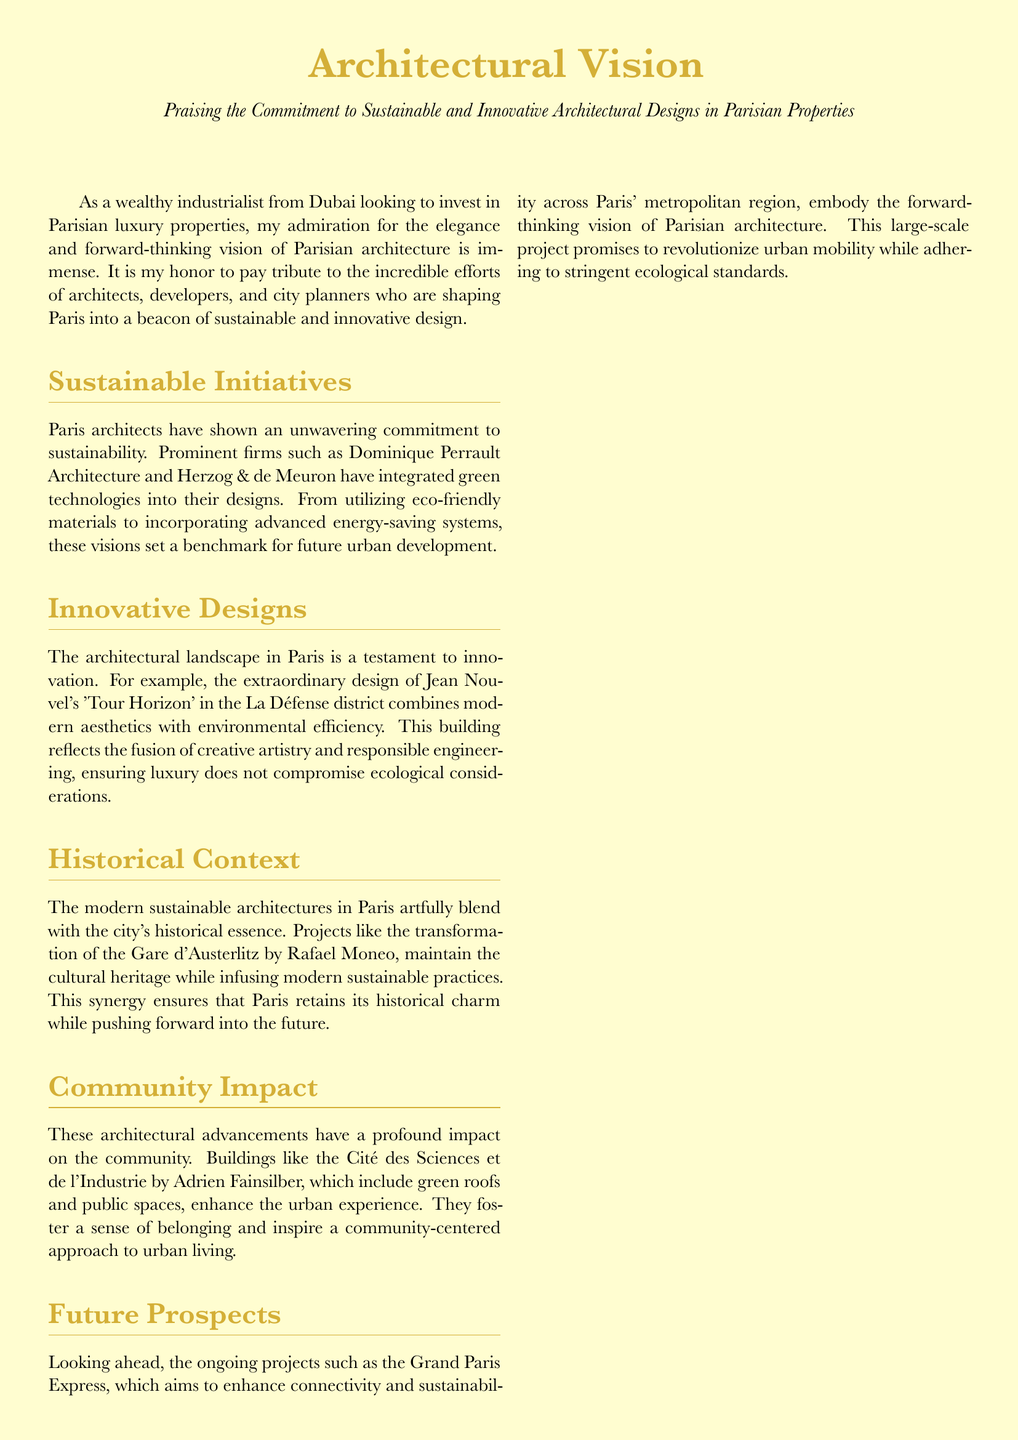What is the name of the architect who designed 'Tour Horizon'? The document mentions Jean Nouvel as the architect of 'Tour Horizon'.
Answer: Jean Nouvel Which firm is noted for integrating green technologies into designs? The document highlights Dominique Perrault Architecture as one of the firms committed to sustainability.
Answer: Dominique Perrault Architecture What project aims to enhance connectivity across Paris? The document states that the Grand Paris Express is the project aiming to enhance connectivity and sustainability.
Answer: Grand Paris Express What feature does the Cité des Sciences et de l'Industrie include? The document mentions that this building includes green roofs and public spaces.
Answer: Green roofs and public spaces Who transformed the Gare d'Austerlitz? The document attributes the transformation of the Gare d'Austerlitz to architect Rafael Moneo.
Answer: Rafael Moneo Which architectural firm is associated with the Cité des Sciences et de l'Industrie? The document identifies Adrien Fainsilber as the architect associated with the Cité des Sciences et de l'Industrie.
Answer: Adrien Fainsilber What is a key characteristic of modern sustainable architectures in Paris? The document states that modern sustainable architectures blend with the city's historical essence.
Answer: Blend with historical essence What does the document laud in Parisian architecture? The document praises the innovation and sustainability in Parisian architecture.
Answer: Innovation and sustainability 